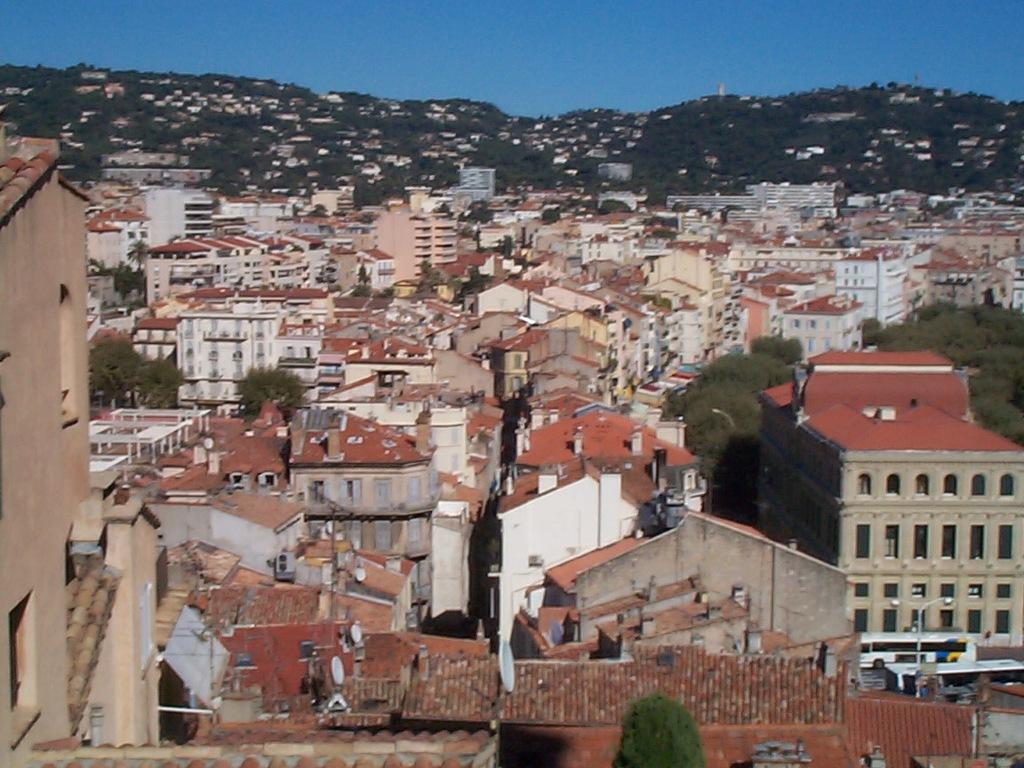What type of structures can be seen in the image? There are buildings in the image. What natural elements are present in the image? There are trees and hills in the image. What type of transportation is visible in the image? There are vehicles in the image. What is attached to the pole in the image? There is a pole with lights in the image. What part of the environment is visible in the image? The sky is visible in the image. What type of treatment is being administered in the image? There is no treatment being administered in the image; it features buildings, trees, hills, vehicles, a pole with lights, and the sky. What type of hall is visible in the image? There is no hall present in the image. 